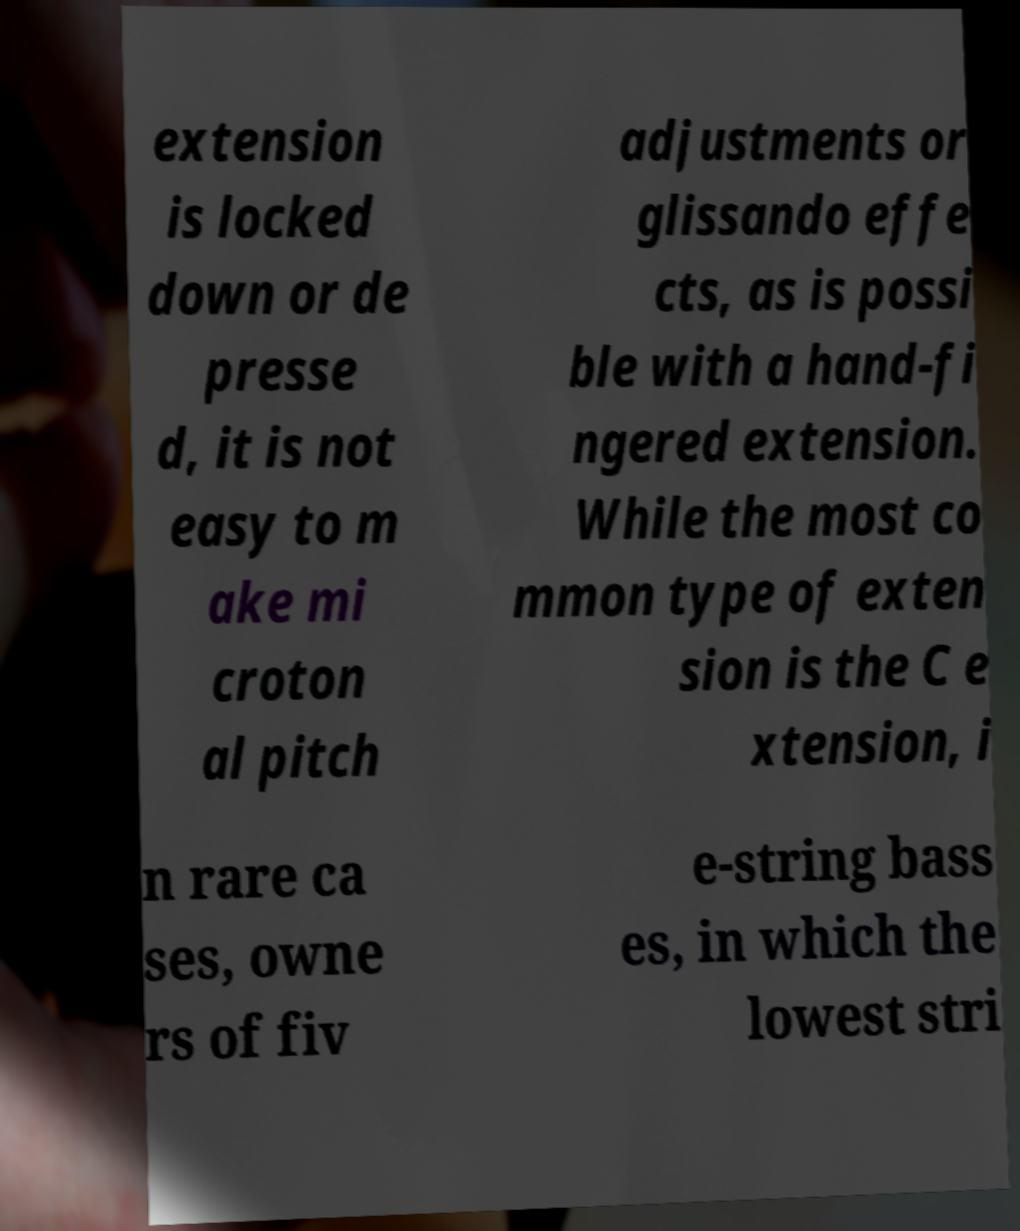Please read and relay the text visible in this image. What does it say? extension is locked down or de presse d, it is not easy to m ake mi croton al pitch adjustments or glissando effe cts, as is possi ble with a hand-fi ngered extension. While the most co mmon type of exten sion is the C e xtension, i n rare ca ses, owne rs of fiv e-string bass es, in which the lowest stri 